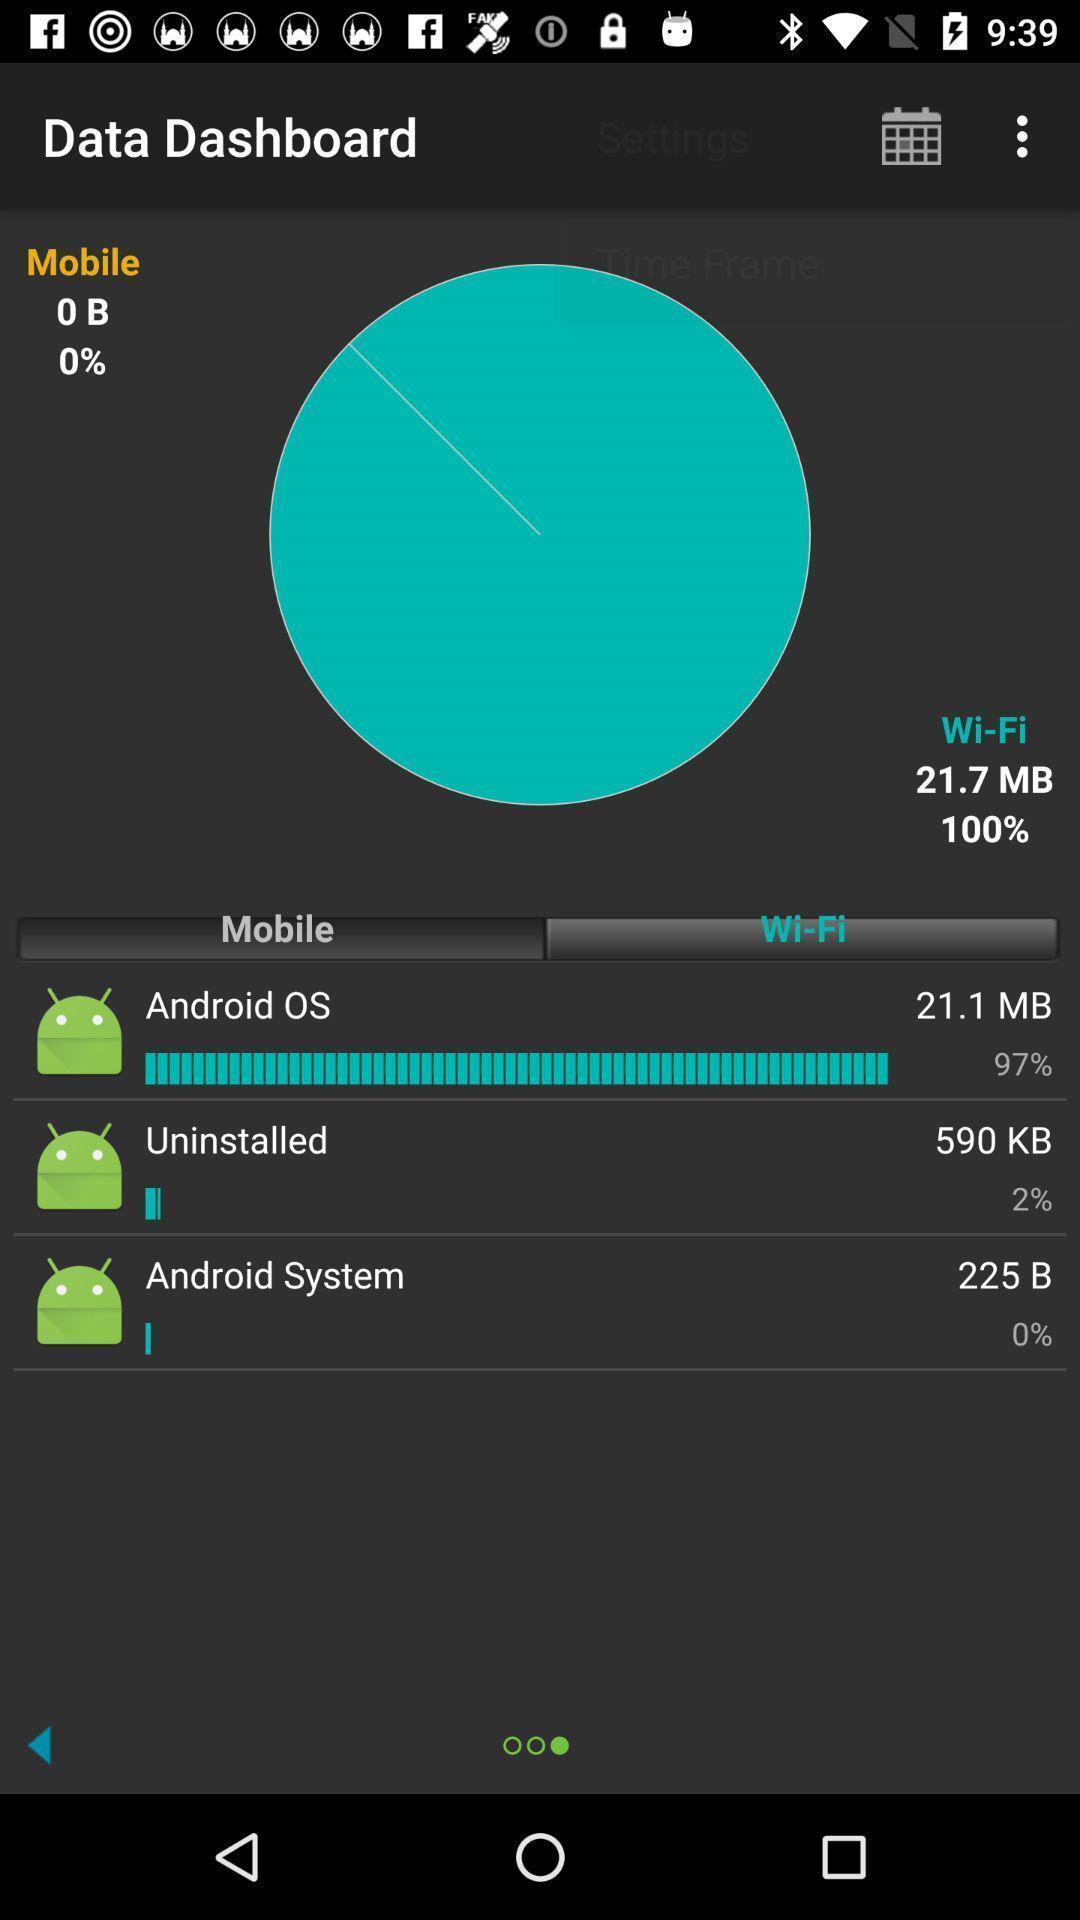Explain what's happening in this screen capture. Page shows the data dashboard details of mobile and wi-fi. 